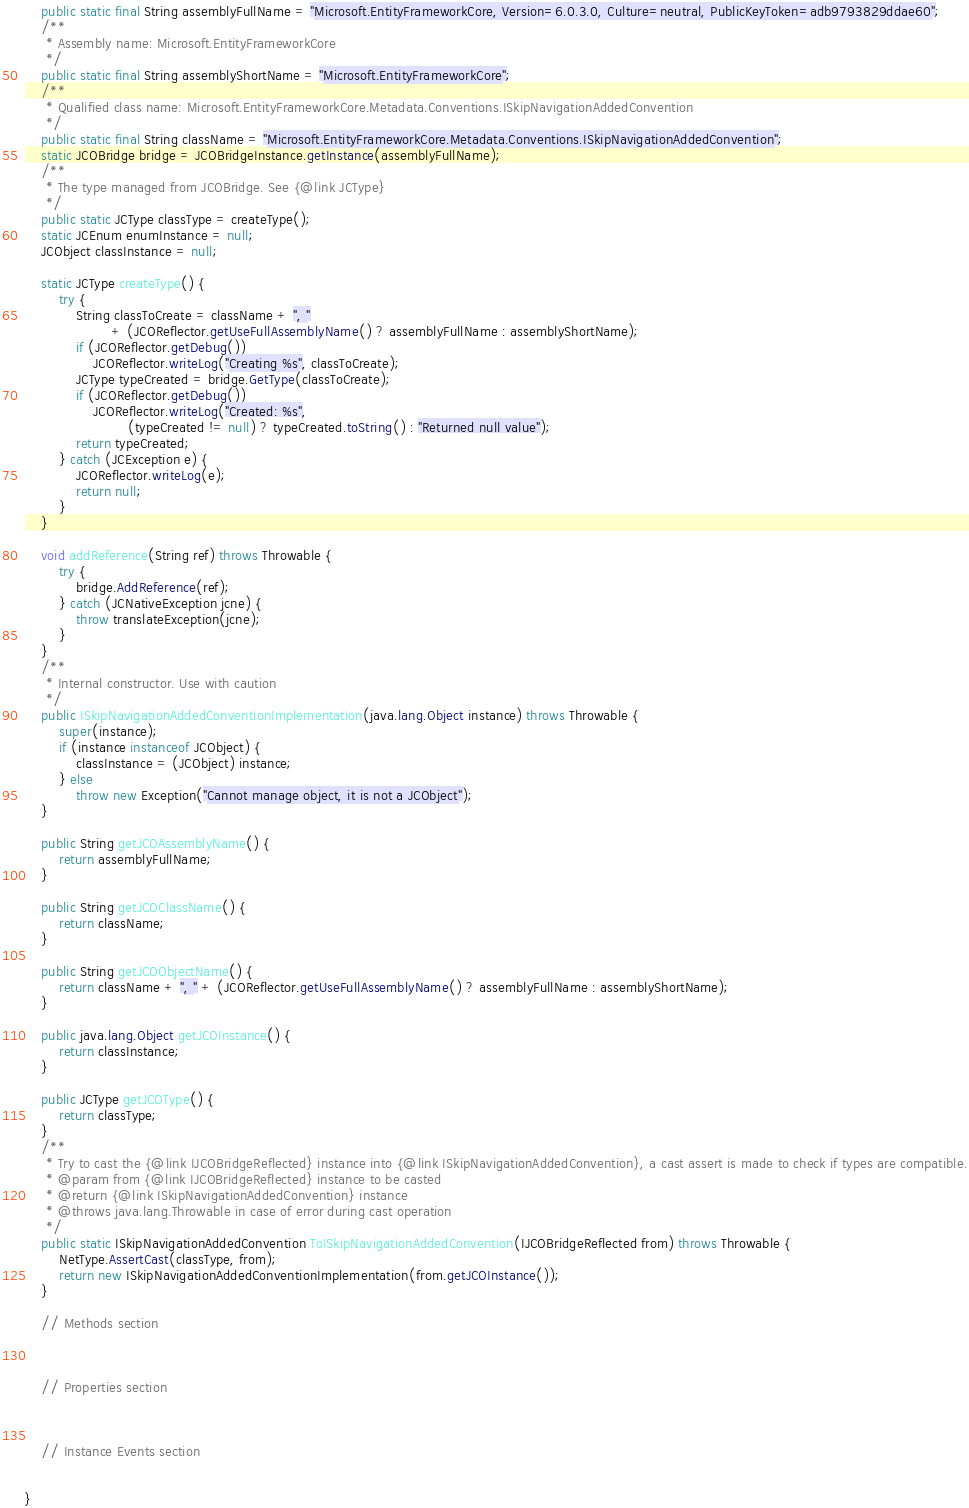Convert code to text. <code><loc_0><loc_0><loc_500><loc_500><_Java_>    public static final String assemblyFullName = "Microsoft.EntityFrameworkCore, Version=6.0.3.0, Culture=neutral, PublicKeyToken=adb9793829ddae60";
    /**
     * Assembly name: Microsoft.EntityFrameworkCore
     */
    public static final String assemblyShortName = "Microsoft.EntityFrameworkCore";
    /**
     * Qualified class name: Microsoft.EntityFrameworkCore.Metadata.Conventions.ISkipNavigationAddedConvention
     */
    public static final String className = "Microsoft.EntityFrameworkCore.Metadata.Conventions.ISkipNavigationAddedConvention";
    static JCOBridge bridge = JCOBridgeInstance.getInstance(assemblyFullName);
    /**
     * The type managed from JCOBridge. See {@link JCType}
     */
    public static JCType classType = createType();
    static JCEnum enumInstance = null;
    JCObject classInstance = null;

    static JCType createType() {
        try {
            String classToCreate = className + ", "
                    + (JCOReflector.getUseFullAssemblyName() ? assemblyFullName : assemblyShortName);
            if (JCOReflector.getDebug())
                JCOReflector.writeLog("Creating %s", classToCreate);
            JCType typeCreated = bridge.GetType(classToCreate);
            if (JCOReflector.getDebug())
                JCOReflector.writeLog("Created: %s",
                        (typeCreated != null) ? typeCreated.toString() : "Returned null value");
            return typeCreated;
        } catch (JCException e) {
            JCOReflector.writeLog(e);
            return null;
        }
    }

    void addReference(String ref) throws Throwable {
        try {
            bridge.AddReference(ref);
        } catch (JCNativeException jcne) {
            throw translateException(jcne);
        }
    }
    /**
     * Internal constructor. Use with caution 
     */
    public ISkipNavigationAddedConventionImplementation(java.lang.Object instance) throws Throwable {
        super(instance);
        if (instance instanceof JCObject) {
            classInstance = (JCObject) instance;
        } else
            throw new Exception("Cannot manage object, it is not a JCObject");
    }

    public String getJCOAssemblyName() {
        return assemblyFullName;
    }

    public String getJCOClassName() {
        return className;
    }

    public String getJCOObjectName() {
        return className + ", " + (JCOReflector.getUseFullAssemblyName() ? assemblyFullName : assemblyShortName);
    }

    public java.lang.Object getJCOInstance() {
        return classInstance;
    }

    public JCType getJCOType() {
        return classType;
    }
    /**
     * Try to cast the {@link IJCOBridgeReflected} instance into {@link ISkipNavigationAddedConvention}, a cast assert is made to check if types are compatible.
     * @param from {@link IJCOBridgeReflected} instance to be casted
     * @return {@link ISkipNavigationAddedConvention} instance
     * @throws java.lang.Throwable in case of error during cast operation
     */
    public static ISkipNavigationAddedConvention ToISkipNavigationAddedConvention(IJCOBridgeReflected from) throws Throwable {
        NetType.AssertCast(classType, from);
        return new ISkipNavigationAddedConventionImplementation(from.getJCOInstance());
    }

    // Methods section
    

    
    // Properties section
    


    // Instance Events section
    

}</code> 